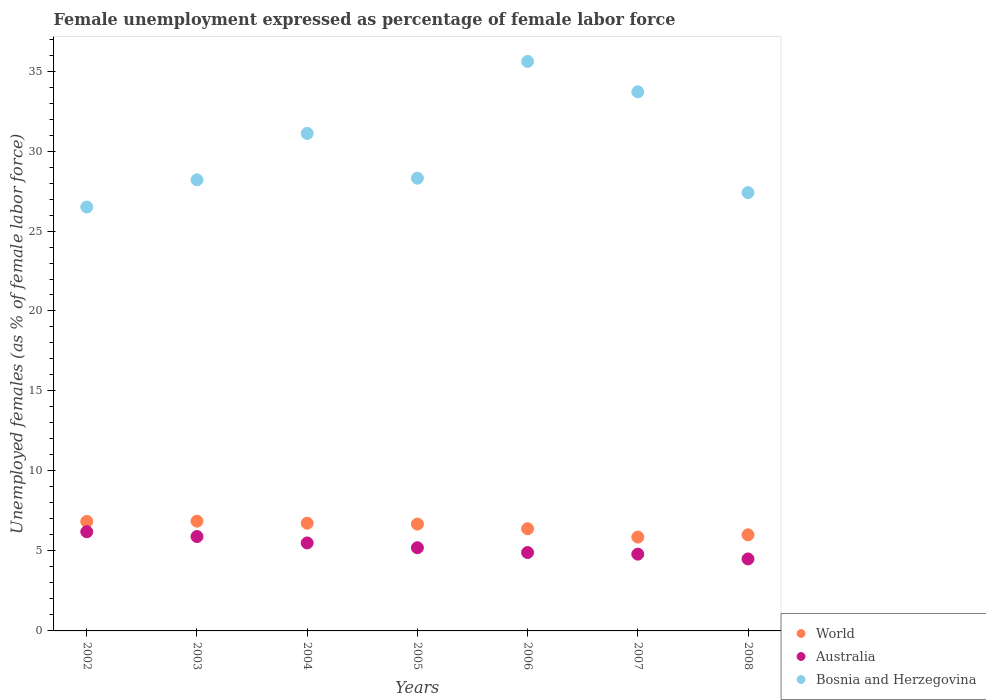Is the number of dotlines equal to the number of legend labels?
Ensure brevity in your answer.  Yes. What is the unemployment in females in in Bosnia and Herzegovina in 2004?
Ensure brevity in your answer.  31.1. Across all years, what is the maximum unemployment in females in in Australia?
Ensure brevity in your answer.  6.2. Across all years, what is the minimum unemployment in females in in Bosnia and Herzegovina?
Your answer should be very brief. 26.5. In which year was the unemployment in females in in Australia maximum?
Offer a terse response. 2002. What is the total unemployment in females in in World in the graph?
Make the answer very short. 45.38. What is the difference between the unemployment in females in in Bosnia and Herzegovina in 2002 and that in 2005?
Provide a short and direct response. -1.8. What is the difference between the unemployment in females in in Australia in 2004 and the unemployment in females in in World in 2008?
Offer a very short reply. -0.51. What is the average unemployment in females in in World per year?
Give a very brief answer. 6.48. In the year 2002, what is the difference between the unemployment in females in in Australia and unemployment in females in in World?
Offer a terse response. -0.64. In how many years, is the unemployment in females in in World greater than 34 %?
Offer a very short reply. 0. What is the ratio of the unemployment in females in in Bosnia and Herzegovina in 2002 to that in 2007?
Keep it short and to the point. 0.79. Is the unemployment in females in in Australia in 2003 less than that in 2004?
Keep it short and to the point. No. Is the difference between the unemployment in females in in Australia in 2006 and 2008 greater than the difference between the unemployment in females in in World in 2006 and 2008?
Your response must be concise. Yes. What is the difference between the highest and the second highest unemployment in females in in World?
Your response must be concise. 0.02. What is the difference between the highest and the lowest unemployment in females in in Australia?
Ensure brevity in your answer.  1.7. In how many years, is the unemployment in females in in Bosnia and Herzegovina greater than the average unemployment in females in in Bosnia and Herzegovina taken over all years?
Ensure brevity in your answer.  3. Is the sum of the unemployment in females in in Bosnia and Herzegovina in 2005 and 2008 greater than the maximum unemployment in females in in World across all years?
Make the answer very short. Yes. Is it the case that in every year, the sum of the unemployment in females in in World and unemployment in females in in Australia  is greater than the unemployment in females in in Bosnia and Herzegovina?
Your answer should be very brief. No. Is the unemployment in females in in Australia strictly less than the unemployment in females in in World over the years?
Make the answer very short. Yes. How many dotlines are there?
Offer a terse response. 3. Does the graph contain any zero values?
Your response must be concise. No. Does the graph contain grids?
Offer a terse response. No. How are the legend labels stacked?
Provide a succinct answer. Vertical. What is the title of the graph?
Provide a short and direct response. Female unemployment expressed as percentage of female labor force. What is the label or title of the X-axis?
Make the answer very short. Years. What is the label or title of the Y-axis?
Make the answer very short. Unemployed females (as % of female labor force). What is the Unemployed females (as % of female labor force) in World in 2002?
Offer a terse response. 6.84. What is the Unemployed females (as % of female labor force) of Australia in 2002?
Ensure brevity in your answer.  6.2. What is the Unemployed females (as % of female labor force) in World in 2003?
Your answer should be compact. 6.86. What is the Unemployed females (as % of female labor force) of Australia in 2003?
Your answer should be very brief. 5.9. What is the Unemployed females (as % of female labor force) in Bosnia and Herzegovina in 2003?
Offer a terse response. 28.2. What is the Unemployed females (as % of female labor force) in World in 2004?
Offer a very short reply. 6.73. What is the Unemployed females (as % of female labor force) in Australia in 2004?
Provide a succinct answer. 5.5. What is the Unemployed females (as % of female labor force) of Bosnia and Herzegovina in 2004?
Offer a terse response. 31.1. What is the Unemployed females (as % of female labor force) in World in 2005?
Provide a short and direct response. 6.68. What is the Unemployed females (as % of female labor force) in Australia in 2005?
Ensure brevity in your answer.  5.2. What is the Unemployed females (as % of female labor force) in Bosnia and Herzegovina in 2005?
Your response must be concise. 28.3. What is the Unemployed females (as % of female labor force) in World in 2006?
Ensure brevity in your answer.  6.39. What is the Unemployed females (as % of female labor force) of Australia in 2006?
Your answer should be compact. 4.9. What is the Unemployed females (as % of female labor force) of Bosnia and Herzegovina in 2006?
Give a very brief answer. 35.6. What is the Unemployed females (as % of female labor force) of World in 2007?
Your answer should be compact. 5.87. What is the Unemployed females (as % of female labor force) in Australia in 2007?
Your answer should be compact. 4.8. What is the Unemployed females (as % of female labor force) in Bosnia and Herzegovina in 2007?
Make the answer very short. 33.7. What is the Unemployed females (as % of female labor force) in World in 2008?
Give a very brief answer. 6.01. What is the Unemployed females (as % of female labor force) in Australia in 2008?
Offer a very short reply. 4.5. What is the Unemployed females (as % of female labor force) in Bosnia and Herzegovina in 2008?
Give a very brief answer. 27.4. Across all years, what is the maximum Unemployed females (as % of female labor force) in World?
Give a very brief answer. 6.86. Across all years, what is the maximum Unemployed females (as % of female labor force) of Australia?
Make the answer very short. 6.2. Across all years, what is the maximum Unemployed females (as % of female labor force) of Bosnia and Herzegovina?
Offer a very short reply. 35.6. Across all years, what is the minimum Unemployed females (as % of female labor force) in World?
Provide a succinct answer. 5.87. Across all years, what is the minimum Unemployed females (as % of female labor force) of Australia?
Provide a succinct answer. 4.5. What is the total Unemployed females (as % of female labor force) in World in the graph?
Make the answer very short. 45.38. What is the total Unemployed females (as % of female labor force) of Bosnia and Herzegovina in the graph?
Provide a succinct answer. 210.8. What is the difference between the Unemployed females (as % of female labor force) in World in 2002 and that in 2003?
Provide a short and direct response. -0.02. What is the difference between the Unemployed females (as % of female labor force) of Australia in 2002 and that in 2003?
Ensure brevity in your answer.  0.3. What is the difference between the Unemployed females (as % of female labor force) of World in 2002 and that in 2004?
Your response must be concise. 0.11. What is the difference between the Unemployed females (as % of female labor force) in Bosnia and Herzegovina in 2002 and that in 2004?
Your answer should be compact. -4.6. What is the difference between the Unemployed females (as % of female labor force) in World in 2002 and that in 2005?
Your answer should be very brief. 0.16. What is the difference between the Unemployed females (as % of female labor force) in World in 2002 and that in 2006?
Make the answer very short. 0.46. What is the difference between the Unemployed females (as % of female labor force) in World in 2002 and that in 2007?
Give a very brief answer. 0.98. What is the difference between the Unemployed females (as % of female labor force) of Australia in 2002 and that in 2007?
Your answer should be compact. 1.4. What is the difference between the Unemployed females (as % of female labor force) of World in 2002 and that in 2008?
Keep it short and to the point. 0.84. What is the difference between the Unemployed females (as % of female labor force) in Australia in 2002 and that in 2008?
Your response must be concise. 1.7. What is the difference between the Unemployed females (as % of female labor force) of Bosnia and Herzegovina in 2002 and that in 2008?
Make the answer very short. -0.9. What is the difference between the Unemployed females (as % of female labor force) in World in 2003 and that in 2004?
Your answer should be very brief. 0.13. What is the difference between the Unemployed females (as % of female labor force) of Australia in 2003 and that in 2004?
Provide a short and direct response. 0.4. What is the difference between the Unemployed females (as % of female labor force) in World in 2003 and that in 2005?
Ensure brevity in your answer.  0.18. What is the difference between the Unemployed females (as % of female labor force) in Bosnia and Herzegovina in 2003 and that in 2005?
Offer a terse response. -0.1. What is the difference between the Unemployed females (as % of female labor force) in World in 2003 and that in 2006?
Give a very brief answer. 0.47. What is the difference between the Unemployed females (as % of female labor force) in Australia in 2003 and that in 2006?
Provide a succinct answer. 1. What is the difference between the Unemployed females (as % of female labor force) in Australia in 2003 and that in 2007?
Make the answer very short. 1.1. What is the difference between the Unemployed females (as % of female labor force) in Bosnia and Herzegovina in 2003 and that in 2007?
Offer a very short reply. -5.5. What is the difference between the Unemployed females (as % of female labor force) of World in 2003 and that in 2008?
Your answer should be very brief. 0.85. What is the difference between the Unemployed females (as % of female labor force) in Australia in 2003 and that in 2008?
Your answer should be compact. 1.4. What is the difference between the Unemployed females (as % of female labor force) in Bosnia and Herzegovina in 2003 and that in 2008?
Keep it short and to the point. 0.8. What is the difference between the Unemployed females (as % of female labor force) of World in 2004 and that in 2005?
Give a very brief answer. 0.05. What is the difference between the Unemployed females (as % of female labor force) of Australia in 2004 and that in 2005?
Provide a short and direct response. 0.3. What is the difference between the Unemployed females (as % of female labor force) in World in 2004 and that in 2006?
Provide a succinct answer. 0.35. What is the difference between the Unemployed females (as % of female labor force) of Bosnia and Herzegovina in 2004 and that in 2006?
Your answer should be very brief. -4.5. What is the difference between the Unemployed females (as % of female labor force) in World in 2004 and that in 2007?
Make the answer very short. 0.87. What is the difference between the Unemployed females (as % of female labor force) in World in 2004 and that in 2008?
Give a very brief answer. 0.73. What is the difference between the Unemployed females (as % of female labor force) in Australia in 2004 and that in 2008?
Your answer should be compact. 1. What is the difference between the Unemployed females (as % of female labor force) in Bosnia and Herzegovina in 2004 and that in 2008?
Give a very brief answer. 3.7. What is the difference between the Unemployed females (as % of female labor force) in World in 2005 and that in 2006?
Your answer should be very brief. 0.29. What is the difference between the Unemployed females (as % of female labor force) in Australia in 2005 and that in 2006?
Give a very brief answer. 0.3. What is the difference between the Unemployed females (as % of female labor force) in Bosnia and Herzegovina in 2005 and that in 2006?
Give a very brief answer. -7.3. What is the difference between the Unemployed females (as % of female labor force) in World in 2005 and that in 2007?
Make the answer very short. 0.81. What is the difference between the Unemployed females (as % of female labor force) in Australia in 2005 and that in 2007?
Make the answer very short. 0.4. What is the difference between the Unemployed females (as % of female labor force) in Bosnia and Herzegovina in 2005 and that in 2007?
Make the answer very short. -5.4. What is the difference between the Unemployed females (as % of female labor force) of World in 2005 and that in 2008?
Give a very brief answer. 0.67. What is the difference between the Unemployed females (as % of female labor force) in Australia in 2005 and that in 2008?
Offer a terse response. 0.7. What is the difference between the Unemployed females (as % of female labor force) of World in 2006 and that in 2007?
Provide a short and direct response. 0.52. What is the difference between the Unemployed females (as % of female labor force) in Australia in 2006 and that in 2007?
Provide a succinct answer. 0.1. What is the difference between the Unemployed females (as % of female labor force) in World in 2006 and that in 2008?
Make the answer very short. 0.38. What is the difference between the Unemployed females (as % of female labor force) of Bosnia and Herzegovina in 2006 and that in 2008?
Your response must be concise. 8.2. What is the difference between the Unemployed females (as % of female labor force) of World in 2007 and that in 2008?
Offer a terse response. -0.14. What is the difference between the Unemployed females (as % of female labor force) of World in 2002 and the Unemployed females (as % of female labor force) of Australia in 2003?
Keep it short and to the point. 0.94. What is the difference between the Unemployed females (as % of female labor force) in World in 2002 and the Unemployed females (as % of female labor force) in Bosnia and Herzegovina in 2003?
Keep it short and to the point. -21.36. What is the difference between the Unemployed females (as % of female labor force) of World in 2002 and the Unemployed females (as % of female labor force) of Australia in 2004?
Your answer should be compact. 1.34. What is the difference between the Unemployed females (as % of female labor force) in World in 2002 and the Unemployed females (as % of female labor force) in Bosnia and Herzegovina in 2004?
Keep it short and to the point. -24.26. What is the difference between the Unemployed females (as % of female labor force) in Australia in 2002 and the Unemployed females (as % of female labor force) in Bosnia and Herzegovina in 2004?
Make the answer very short. -24.9. What is the difference between the Unemployed females (as % of female labor force) of World in 2002 and the Unemployed females (as % of female labor force) of Australia in 2005?
Your answer should be very brief. 1.64. What is the difference between the Unemployed females (as % of female labor force) in World in 2002 and the Unemployed females (as % of female labor force) in Bosnia and Herzegovina in 2005?
Your answer should be very brief. -21.46. What is the difference between the Unemployed females (as % of female labor force) in Australia in 2002 and the Unemployed females (as % of female labor force) in Bosnia and Herzegovina in 2005?
Offer a very short reply. -22.1. What is the difference between the Unemployed females (as % of female labor force) in World in 2002 and the Unemployed females (as % of female labor force) in Australia in 2006?
Your response must be concise. 1.94. What is the difference between the Unemployed females (as % of female labor force) in World in 2002 and the Unemployed females (as % of female labor force) in Bosnia and Herzegovina in 2006?
Provide a succinct answer. -28.76. What is the difference between the Unemployed females (as % of female labor force) of Australia in 2002 and the Unemployed females (as % of female labor force) of Bosnia and Herzegovina in 2006?
Your answer should be compact. -29.4. What is the difference between the Unemployed females (as % of female labor force) of World in 2002 and the Unemployed females (as % of female labor force) of Australia in 2007?
Your response must be concise. 2.04. What is the difference between the Unemployed females (as % of female labor force) in World in 2002 and the Unemployed females (as % of female labor force) in Bosnia and Herzegovina in 2007?
Ensure brevity in your answer.  -26.86. What is the difference between the Unemployed females (as % of female labor force) in Australia in 2002 and the Unemployed females (as % of female labor force) in Bosnia and Herzegovina in 2007?
Provide a short and direct response. -27.5. What is the difference between the Unemployed females (as % of female labor force) of World in 2002 and the Unemployed females (as % of female labor force) of Australia in 2008?
Give a very brief answer. 2.34. What is the difference between the Unemployed females (as % of female labor force) in World in 2002 and the Unemployed females (as % of female labor force) in Bosnia and Herzegovina in 2008?
Provide a succinct answer. -20.56. What is the difference between the Unemployed females (as % of female labor force) of Australia in 2002 and the Unemployed females (as % of female labor force) of Bosnia and Herzegovina in 2008?
Your answer should be compact. -21.2. What is the difference between the Unemployed females (as % of female labor force) of World in 2003 and the Unemployed females (as % of female labor force) of Australia in 2004?
Offer a very short reply. 1.36. What is the difference between the Unemployed females (as % of female labor force) in World in 2003 and the Unemployed females (as % of female labor force) in Bosnia and Herzegovina in 2004?
Provide a succinct answer. -24.24. What is the difference between the Unemployed females (as % of female labor force) of Australia in 2003 and the Unemployed females (as % of female labor force) of Bosnia and Herzegovina in 2004?
Give a very brief answer. -25.2. What is the difference between the Unemployed females (as % of female labor force) of World in 2003 and the Unemployed females (as % of female labor force) of Australia in 2005?
Provide a succinct answer. 1.66. What is the difference between the Unemployed females (as % of female labor force) in World in 2003 and the Unemployed females (as % of female labor force) in Bosnia and Herzegovina in 2005?
Offer a very short reply. -21.44. What is the difference between the Unemployed females (as % of female labor force) in Australia in 2003 and the Unemployed females (as % of female labor force) in Bosnia and Herzegovina in 2005?
Your response must be concise. -22.4. What is the difference between the Unemployed females (as % of female labor force) of World in 2003 and the Unemployed females (as % of female labor force) of Australia in 2006?
Give a very brief answer. 1.96. What is the difference between the Unemployed females (as % of female labor force) in World in 2003 and the Unemployed females (as % of female labor force) in Bosnia and Herzegovina in 2006?
Make the answer very short. -28.74. What is the difference between the Unemployed females (as % of female labor force) in Australia in 2003 and the Unemployed females (as % of female labor force) in Bosnia and Herzegovina in 2006?
Offer a terse response. -29.7. What is the difference between the Unemployed females (as % of female labor force) of World in 2003 and the Unemployed females (as % of female labor force) of Australia in 2007?
Your answer should be compact. 2.06. What is the difference between the Unemployed females (as % of female labor force) in World in 2003 and the Unemployed females (as % of female labor force) in Bosnia and Herzegovina in 2007?
Provide a succinct answer. -26.84. What is the difference between the Unemployed females (as % of female labor force) of Australia in 2003 and the Unemployed females (as % of female labor force) of Bosnia and Herzegovina in 2007?
Keep it short and to the point. -27.8. What is the difference between the Unemployed females (as % of female labor force) in World in 2003 and the Unemployed females (as % of female labor force) in Australia in 2008?
Offer a terse response. 2.36. What is the difference between the Unemployed females (as % of female labor force) in World in 2003 and the Unemployed females (as % of female labor force) in Bosnia and Herzegovina in 2008?
Provide a succinct answer. -20.54. What is the difference between the Unemployed females (as % of female labor force) in Australia in 2003 and the Unemployed females (as % of female labor force) in Bosnia and Herzegovina in 2008?
Provide a short and direct response. -21.5. What is the difference between the Unemployed females (as % of female labor force) in World in 2004 and the Unemployed females (as % of female labor force) in Australia in 2005?
Offer a very short reply. 1.53. What is the difference between the Unemployed females (as % of female labor force) in World in 2004 and the Unemployed females (as % of female labor force) in Bosnia and Herzegovina in 2005?
Provide a short and direct response. -21.57. What is the difference between the Unemployed females (as % of female labor force) in Australia in 2004 and the Unemployed females (as % of female labor force) in Bosnia and Herzegovina in 2005?
Make the answer very short. -22.8. What is the difference between the Unemployed females (as % of female labor force) in World in 2004 and the Unemployed females (as % of female labor force) in Australia in 2006?
Your answer should be very brief. 1.83. What is the difference between the Unemployed females (as % of female labor force) in World in 2004 and the Unemployed females (as % of female labor force) in Bosnia and Herzegovina in 2006?
Provide a succinct answer. -28.87. What is the difference between the Unemployed females (as % of female labor force) in Australia in 2004 and the Unemployed females (as % of female labor force) in Bosnia and Herzegovina in 2006?
Offer a very short reply. -30.1. What is the difference between the Unemployed females (as % of female labor force) of World in 2004 and the Unemployed females (as % of female labor force) of Australia in 2007?
Provide a short and direct response. 1.93. What is the difference between the Unemployed females (as % of female labor force) in World in 2004 and the Unemployed females (as % of female labor force) in Bosnia and Herzegovina in 2007?
Give a very brief answer. -26.97. What is the difference between the Unemployed females (as % of female labor force) in Australia in 2004 and the Unemployed females (as % of female labor force) in Bosnia and Herzegovina in 2007?
Offer a terse response. -28.2. What is the difference between the Unemployed females (as % of female labor force) of World in 2004 and the Unemployed females (as % of female labor force) of Australia in 2008?
Make the answer very short. 2.23. What is the difference between the Unemployed females (as % of female labor force) in World in 2004 and the Unemployed females (as % of female labor force) in Bosnia and Herzegovina in 2008?
Ensure brevity in your answer.  -20.67. What is the difference between the Unemployed females (as % of female labor force) in Australia in 2004 and the Unemployed females (as % of female labor force) in Bosnia and Herzegovina in 2008?
Offer a terse response. -21.9. What is the difference between the Unemployed females (as % of female labor force) of World in 2005 and the Unemployed females (as % of female labor force) of Australia in 2006?
Provide a short and direct response. 1.78. What is the difference between the Unemployed females (as % of female labor force) of World in 2005 and the Unemployed females (as % of female labor force) of Bosnia and Herzegovina in 2006?
Ensure brevity in your answer.  -28.92. What is the difference between the Unemployed females (as % of female labor force) in Australia in 2005 and the Unemployed females (as % of female labor force) in Bosnia and Herzegovina in 2006?
Your answer should be very brief. -30.4. What is the difference between the Unemployed females (as % of female labor force) in World in 2005 and the Unemployed females (as % of female labor force) in Australia in 2007?
Your response must be concise. 1.88. What is the difference between the Unemployed females (as % of female labor force) in World in 2005 and the Unemployed females (as % of female labor force) in Bosnia and Herzegovina in 2007?
Ensure brevity in your answer.  -27.02. What is the difference between the Unemployed females (as % of female labor force) in Australia in 2005 and the Unemployed females (as % of female labor force) in Bosnia and Herzegovina in 2007?
Your answer should be compact. -28.5. What is the difference between the Unemployed females (as % of female labor force) in World in 2005 and the Unemployed females (as % of female labor force) in Australia in 2008?
Make the answer very short. 2.18. What is the difference between the Unemployed females (as % of female labor force) of World in 2005 and the Unemployed females (as % of female labor force) of Bosnia and Herzegovina in 2008?
Keep it short and to the point. -20.72. What is the difference between the Unemployed females (as % of female labor force) of Australia in 2005 and the Unemployed females (as % of female labor force) of Bosnia and Herzegovina in 2008?
Offer a terse response. -22.2. What is the difference between the Unemployed females (as % of female labor force) of World in 2006 and the Unemployed females (as % of female labor force) of Australia in 2007?
Ensure brevity in your answer.  1.59. What is the difference between the Unemployed females (as % of female labor force) in World in 2006 and the Unemployed females (as % of female labor force) in Bosnia and Herzegovina in 2007?
Make the answer very short. -27.31. What is the difference between the Unemployed females (as % of female labor force) of Australia in 2006 and the Unemployed females (as % of female labor force) of Bosnia and Herzegovina in 2007?
Make the answer very short. -28.8. What is the difference between the Unemployed females (as % of female labor force) of World in 2006 and the Unemployed females (as % of female labor force) of Australia in 2008?
Ensure brevity in your answer.  1.89. What is the difference between the Unemployed females (as % of female labor force) of World in 2006 and the Unemployed females (as % of female labor force) of Bosnia and Herzegovina in 2008?
Your answer should be very brief. -21.01. What is the difference between the Unemployed females (as % of female labor force) in Australia in 2006 and the Unemployed females (as % of female labor force) in Bosnia and Herzegovina in 2008?
Your answer should be very brief. -22.5. What is the difference between the Unemployed females (as % of female labor force) in World in 2007 and the Unemployed females (as % of female labor force) in Australia in 2008?
Make the answer very short. 1.37. What is the difference between the Unemployed females (as % of female labor force) of World in 2007 and the Unemployed females (as % of female labor force) of Bosnia and Herzegovina in 2008?
Provide a succinct answer. -21.53. What is the difference between the Unemployed females (as % of female labor force) of Australia in 2007 and the Unemployed females (as % of female labor force) of Bosnia and Herzegovina in 2008?
Ensure brevity in your answer.  -22.6. What is the average Unemployed females (as % of female labor force) of World per year?
Ensure brevity in your answer.  6.48. What is the average Unemployed females (as % of female labor force) in Australia per year?
Offer a terse response. 5.29. What is the average Unemployed females (as % of female labor force) of Bosnia and Herzegovina per year?
Keep it short and to the point. 30.11. In the year 2002, what is the difference between the Unemployed females (as % of female labor force) in World and Unemployed females (as % of female labor force) in Australia?
Offer a very short reply. 0.64. In the year 2002, what is the difference between the Unemployed females (as % of female labor force) in World and Unemployed females (as % of female labor force) in Bosnia and Herzegovina?
Your answer should be compact. -19.66. In the year 2002, what is the difference between the Unemployed females (as % of female labor force) of Australia and Unemployed females (as % of female labor force) of Bosnia and Herzegovina?
Make the answer very short. -20.3. In the year 2003, what is the difference between the Unemployed females (as % of female labor force) in World and Unemployed females (as % of female labor force) in Bosnia and Herzegovina?
Offer a terse response. -21.34. In the year 2003, what is the difference between the Unemployed females (as % of female labor force) of Australia and Unemployed females (as % of female labor force) of Bosnia and Herzegovina?
Give a very brief answer. -22.3. In the year 2004, what is the difference between the Unemployed females (as % of female labor force) of World and Unemployed females (as % of female labor force) of Australia?
Make the answer very short. 1.23. In the year 2004, what is the difference between the Unemployed females (as % of female labor force) of World and Unemployed females (as % of female labor force) of Bosnia and Herzegovina?
Give a very brief answer. -24.37. In the year 2004, what is the difference between the Unemployed females (as % of female labor force) of Australia and Unemployed females (as % of female labor force) of Bosnia and Herzegovina?
Offer a terse response. -25.6. In the year 2005, what is the difference between the Unemployed females (as % of female labor force) of World and Unemployed females (as % of female labor force) of Australia?
Ensure brevity in your answer.  1.48. In the year 2005, what is the difference between the Unemployed females (as % of female labor force) in World and Unemployed females (as % of female labor force) in Bosnia and Herzegovina?
Give a very brief answer. -21.62. In the year 2005, what is the difference between the Unemployed females (as % of female labor force) of Australia and Unemployed females (as % of female labor force) of Bosnia and Herzegovina?
Your answer should be very brief. -23.1. In the year 2006, what is the difference between the Unemployed females (as % of female labor force) in World and Unemployed females (as % of female labor force) in Australia?
Keep it short and to the point. 1.49. In the year 2006, what is the difference between the Unemployed females (as % of female labor force) of World and Unemployed females (as % of female labor force) of Bosnia and Herzegovina?
Give a very brief answer. -29.21. In the year 2006, what is the difference between the Unemployed females (as % of female labor force) in Australia and Unemployed females (as % of female labor force) in Bosnia and Herzegovina?
Your answer should be compact. -30.7. In the year 2007, what is the difference between the Unemployed females (as % of female labor force) in World and Unemployed females (as % of female labor force) in Australia?
Your answer should be very brief. 1.07. In the year 2007, what is the difference between the Unemployed females (as % of female labor force) of World and Unemployed females (as % of female labor force) of Bosnia and Herzegovina?
Offer a terse response. -27.83. In the year 2007, what is the difference between the Unemployed females (as % of female labor force) in Australia and Unemployed females (as % of female labor force) in Bosnia and Herzegovina?
Your answer should be compact. -28.9. In the year 2008, what is the difference between the Unemployed females (as % of female labor force) of World and Unemployed females (as % of female labor force) of Australia?
Ensure brevity in your answer.  1.51. In the year 2008, what is the difference between the Unemployed females (as % of female labor force) of World and Unemployed females (as % of female labor force) of Bosnia and Herzegovina?
Your response must be concise. -21.39. In the year 2008, what is the difference between the Unemployed females (as % of female labor force) in Australia and Unemployed females (as % of female labor force) in Bosnia and Herzegovina?
Your response must be concise. -22.9. What is the ratio of the Unemployed females (as % of female labor force) of World in 2002 to that in 2003?
Your answer should be very brief. 1. What is the ratio of the Unemployed females (as % of female labor force) of Australia in 2002 to that in 2003?
Your response must be concise. 1.05. What is the ratio of the Unemployed females (as % of female labor force) of Bosnia and Herzegovina in 2002 to that in 2003?
Offer a terse response. 0.94. What is the ratio of the Unemployed females (as % of female labor force) of World in 2002 to that in 2004?
Make the answer very short. 1.02. What is the ratio of the Unemployed females (as % of female labor force) in Australia in 2002 to that in 2004?
Your answer should be compact. 1.13. What is the ratio of the Unemployed females (as % of female labor force) of Bosnia and Herzegovina in 2002 to that in 2004?
Keep it short and to the point. 0.85. What is the ratio of the Unemployed females (as % of female labor force) of World in 2002 to that in 2005?
Your answer should be compact. 1.02. What is the ratio of the Unemployed females (as % of female labor force) of Australia in 2002 to that in 2005?
Provide a short and direct response. 1.19. What is the ratio of the Unemployed females (as % of female labor force) in Bosnia and Herzegovina in 2002 to that in 2005?
Give a very brief answer. 0.94. What is the ratio of the Unemployed females (as % of female labor force) of World in 2002 to that in 2006?
Keep it short and to the point. 1.07. What is the ratio of the Unemployed females (as % of female labor force) in Australia in 2002 to that in 2006?
Keep it short and to the point. 1.27. What is the ratio of the Unemployed females (as % of female labor force) of Bosnia and Herzegovina in 2002 to that in 2006?
Give a very brief answer. 0.74. What is the ratio of the Unemployed females (as % of female labor force) of World in 2002 to that in 2007?
Your answer should be very brief. 1.17. What is the ratio of the Unemployed females (as % of female labor force) of Australia in 2002 to that in 2007?
Give a very brief answer. 1.29. What is the ratio of the Unemployed females (as % of female labor force) of Bosnia and Herzegovina in 2002 to that in 2007?
Offer a terse response. 0.79. What is the ratio of the Unemployed females (as % of female labor force) of World in 2002 to that in 2008?
Keep it short and to the point. 1.14. What is the ratio of the Unemployed females (as % of female labor force) of Australia in 2002 to that in 2008?
Give a very brief answer. 1.38. What is the ratio of the Unemployed females (as % of female labor force) of Bosnia and Herzegovina in 2002 to that in 2008?
Your response must be concise. 0.97. What is the ratio of the Unemployed females (as % of female labor force) of World in 2003 to that in 2004?
Ensure brevity in your answer.  1.02. What is the ratio of the Unemployed females (as % of female labor force) of Australia in 2003 to that in 2004?
Keep it short and to the point. 1.07. What is the ratio of the Unemployed females (as % of female labor force) in Bosnia and Herzegovina in 2003 to that in 2004?
Give a very brief answer. 0.91. What is the ratio of the Unemployed females (as % of female labor force) in World in 2003 to that in 2005?
Make the answer very short. 1.03. What is the ratio of the Unemployed females (as % of female labor force) in Australia in 2003 to that in 2005?
Provide a succinct answer. 1.13. What is the ratio of the Unemployed females (as % of female labor force) in World in 2003 to that in 2006?
Ensure brevity in your answer.  1.07. What is the ratio of the Unemployed females (as % of female labor force) of Australia in 2003 to that in 2006?
Provide a succinct answer. 1.2. What is the ratio of the Unemployed females (as % of female labor force) in Bosnia and Herzegovina in 2003 to that in 2006?
Your answer should be compact. 0.79. What is the ratio of the Unemployed females (as % of female labor force) of World in 2003 to that in 2007?
Your answer should be compact. 1.17. What is the ratio of the Unemployed females (as % of female labor force) of Australia in 2003 to that in 2007?
Provide a short and direct response. 1.23. What is the ratio of the Unemployed females (as % of female labor force) of Bosnia and Herzegovina in 2003 to that in 2007?
Ensure brevity in your answer.  0.84. What is the ratio of the Unemployed females (as % of female labor force) of World in 2003 to that in 2008?
Give a very brief answer. 1.14. What is the ratio of the Unemployed females (as % of female labor force) of Australia in 2003 to that in 2008?
Make the answer very short. 1.31. What is the ratio of the Unemployed females (as % of female labor force) in Bosnia and Herzegovina in 2003 to that in 2008?
Your answer should be very brief. 1.03. What is the ratio of the Unemployed females (as % of female labor force) in Australia in 2004 to that in 2005?
Offer a terse response. 1.06. What is the ratio of the Unemployed females (as % of female labor force) in Bosnia and Herzegovina in 2004 to that in 2005?
Provide a short and direct response. 1.1. What is the ratio of the Unemployed females (as % of female labor force) of World in 2004 to that in 2006?
Offer a very short reply. 1.05. What is the ratio of the Unemployed females (as % of female labor force) of Australia in 2004 to that in 2006?
Give a very brief answer. 1.12. What is the ratio of the Unemployed females (as % of female labor force) of Bosnia and Herzegovina in 2004 to that in 2006?
Provide a short and direct response. 0.87. What is the ratio of the Unemployed females (as % of female labor force) of World in 2004 to that in 2007?
Your response must be concise. 1.15. What is the ratio of the Unemployed females (as % of female labor force) in Australia in 2004 to that in 2007?
Provide a short and direct response. 1.15. What is the ratio of the Unemployed females (as % of female labor force) in Bosnia and Herzegovina in 2004 to that in 2007?
Provide a short and direct response. 0.92. What is the ratio of the Unemployed females (as % of female labor force) of World in 2004 to that in 2008?
Ensure brevity in your answer.  1.12. What is the ratio of the Unemployed females (as % of female labor force) in Australia in 2004 to that in 2008?
Give a very brief answer. 1.22. What is the ratio of the Unemployed females (as % of female labor force) of Bosnia and Herzegovina in 2004 to that in 2008?
Your answer should be compact. 1.14. What is the ratio of the Unemployed females (as % of female labor force) of World in 2005 to that in 2006?
Provide a short and direct response. 1.05. What is the ratio of the Unemployed females (as % of female labor force) of Australia in 2005 to that in 2006?
Your response must be concise. 1.06. What is the ratio of the Unemployed females (as % of female labor force) of Bosnia and Herzegovina in 2005 to that in 2006?
Offer a very short reply. 0.79. What is the ratio of the Unemployed females (as % of female labor force) of World in 2005 to that in 2007?
Provide a short and direct response. 1.14. What is the ratio of the Unemployed females (as % of female labor force) of Bosnia and Herzegovina in 2005 to that in 2007?
Provide a succinct answer. 0.84. What is the ratio of the Unemployed females (as % of female labor force) in World in 2005 to that in 2008?
Offer a terse response. 1.11. What is the ratio of the Unemployed females (as % of female labor force) in Australia in 2005 to that in 2008?
Give a very brief answer. 1.16. What is the ratio of the Unemployed females (as % of female labor force) of Bosnia and Herzegovina in 2005 to that in 2008?
Your answer should be compact. 1.03. What is the ratio of the Unemployed females (as % of female labor force) in World in 2006 to that in 2007?
Provide a short and direct response. 1.09. What is the ratio of the Unemployed females (as % of female labor force) of Australia in 2006 to that in 2007?
Give a very brief answer. 1.02. What is the ratio of the Unemployed females (as % of female labor force) of Bosnia and Herzegovina in 2006 to that in 2007?
Your answer should be very brief. 1.06. What is the ratio of the Unemployed females (as % of female labor force) in World in 2006 to that in 2008?
Offer a terse response. 1.06. What is the ratio of the Unemployed females (as % of female labor force) of Australia in 2006 to that in 2008?
Offer a very short reply. 1.09. What is the ratio of the Unemployed females (as % of female labor force) in Bosnia and Herzegovina in 2006 to that in 2008?
Your response must be concise. 1.3. What is the ratio of the Unemployed females (as % of female labor force) in World in 2007 to that in 2008?
Offer a terse response. 0.98. What is the ratio of the Unemployed females (as % of female labor force) in Australia in 2007 to that in 2008?
Offer a terse response. 1.07. What is the ratio of the Unemployed females (as % of female labor force) of Bosnia and Herzegovina in 2007 to that in 2008?
Give a very brief answer. 1.23. What is the difference between the highest and the second highest Unemployed females (as % of female labor force) of World?
Keep it short and to the point. 0.02. What is the difference between the highest and the second highest Unemployed females (as % of female labor force) in Bosnia and Herzegovina?
Your response must be concise. 1.9. What is the difference between the highest and the lowest Unemployed females (as % of female labor force) in World?
Your answer should be compact. 1. What is the difference between the highest and the lowest Unemployed females (as % of female labor force) of Bosnia and Herzegovina?
Ensure brevity in your answer.  9.1. 